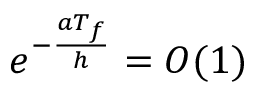<formula> <loc_0><loc_0><loc_500><loc_500>e ^ { - \frac { a T _ { f } } { h } } = O ( 1 )</formula> 